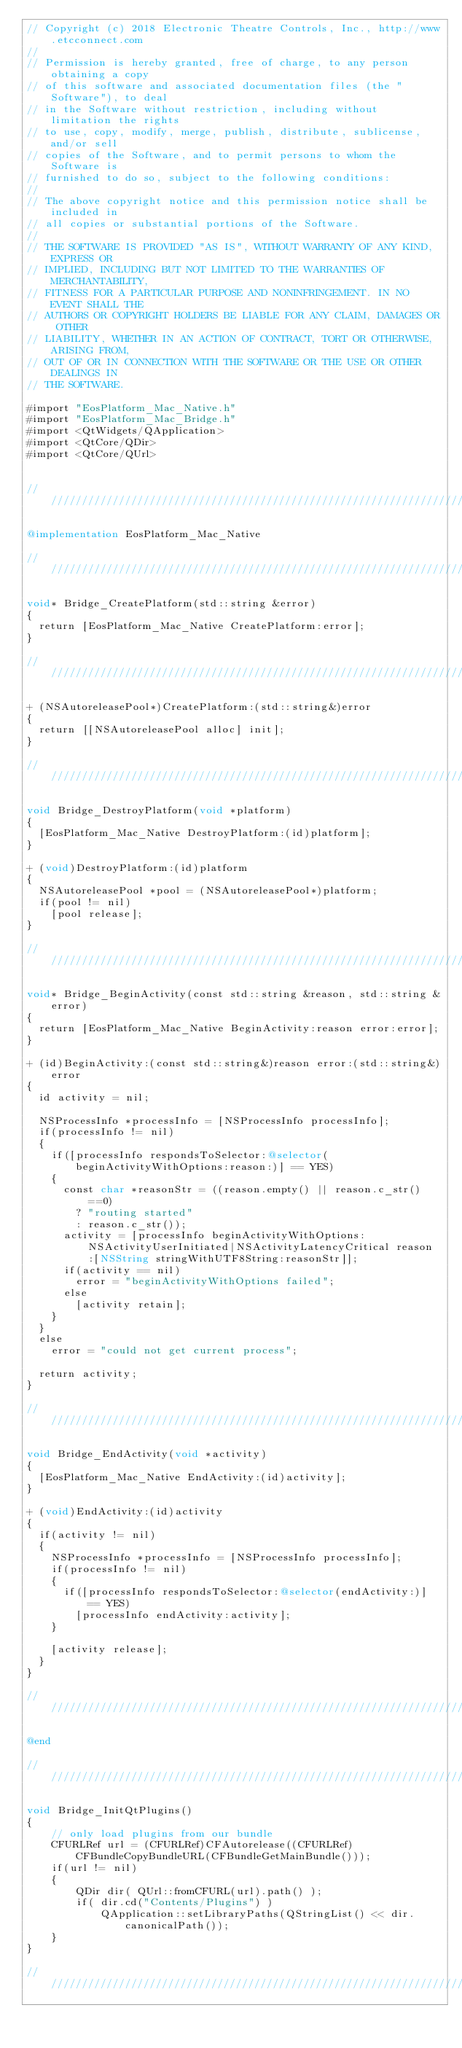<code> <loc_0><loc_0><loc_500><loc_500><_ObjectiveC_>// Copyright (c) 2018 Electronic Theatre Controls, Inc., http://www.etcconnect.com
//
// Permission is hereby granted, free of charge, to any person obtaining a copy
// of this software and associated documentation files (the "Software"), to deal
// in the Software without restriction, including without limitation the rights
// to use, copy, modify, merge, publish, distribute, sublicense, and/or sell
// copies of the Software, and to permit persons to whom the Software is
// furnished to do so, subject to the following conditions:
//
// The above copyright notice and this permission notice shall be included in
// all copies or substantial portions of the Software.
//
// THE SOFTWARE IS PROVIDED "AS IS", WITHOUT WARRANTY OF ANY KIND, EXPRESS OR
// IMPLIED, INCLUDING BUT NOT LIMITED TO THE WARRANTIES OF MERCHANTABILITY,
// FITNESS FOR A PARTICULAR PURPOSE AND NONINFRINGEMENT. IN NO EVENT SHALL THE
// AUTHORS OR COPYRIGHT HOLDERS BE LIABLE FOR ANY CLAIM, DAMAGES OR OTHER
// LIABILITY, WHETHER IN AN ACTION OF CONTRACT, TORT OR OTHERWISE, ARISING FROM,
// OUT OF OR IN CONNECTION WITH THE SOFTWARE OR THE USE OR OTHER DEALINGS IN
// THE SOFTWARE.

#import "EosPlatform_Mac_Native.h"
#import "EosPlatform_Mac_Bridge.h"
#import <QtWidgets/QApplication>
#import <QtCore/QDir>
#import <QtCore/QUrl>


////////////////////////////////////////////////////////////////////////////////

@implementation EosPlatform_Mac_Native

////////////////////////////////////////////////////////////////////////////////

void* Bridge_CreatePlatform(std::string &error)
{
	return [EosPlatform_Mac_Native CreatePlatform:error];
}

////////////////////////////////////////////////////////////////////////////////

+ (NSAutoreleasePool*)CreatePlatform:(std::string&)error
{
	return [[NSAutoreleasePool alloc] init];
}

////////////////////////////////////////////////////////////////////////////////

void Bridge_DestroyPlatform(void *platform)
{
	[EosPlatform_Mac_Native DestroyPlatform:(id)platform];
}

+ (void)DestroyPlatform:(id)platform
{
	NSAutoreleasePool *pool = (NSAutoreleasePool*)platform;
	if(pool != nil)
		[pool release];
}

////////////////////////////////////////////////////////////////////////////////

void* Bridge_BeginActivity(const std::string &reason, std::string &error)
{
	return [EosPlatform_Mac_Native BeginActivity:reason error:error];
}

+ (id)BeginActivity:(const std::string&)reason error:(std::string&)error
{
	id activity = nil;
	
	NSProcessInfo *processInfo = [NSProcessInfo processInfo];
	if(processInfo != nil)
	{
		if([processInfo respondsToSelector:@selector(beginActivityWithOptions:reason:)] == YES)
		{
			const char *reasonStr = ((reason.empty() || reason.c_str()==0)
				? "routing started"
				: reason.c_str());
			activity = [processInfo beginActivityWithOptions:NSActivityUserInitiated|NSActivityLatencyCritical reason:[NSString stringWithUTF8String:reasonStr]];
			if(activity == nil)
				error = "beginActivityWithOptions failed";
			else
				[activity retain];
		}
	}
	else
		error = "could not get current process";
	
	return activity;
}

////////////////////////////////////////////////////////////////////////////////

void Bridge_EndActivity(void *activity)
{
	[EosPlatform_Mac_Native EndActivity:(id)activity];
}

+ (void)EndActivity:(id)activity
{
	if(activity != nil)
	{
		NSProcessInfo *processInfo = [NSProcessInfo processInfo];
		if(processInfo != nil)
		{
			if([processInfo respondsToSelector:@selector(endActivity:)] == YES)
				[processInfo endActivity:activity];
		}
		
		[activity release];
	}
}

////////////////////////////////////////////////////////////////////////////////

@end

////////////////////////////////////////////////////////////////////////////////

void Bridge_InitQtPlugins()
{
    // only load plugins from our bundle
    CFURLRef url = (CFURLRef)CFAutorelease((CFURLRef)CFBundleCopyBundleURL(CFBundleGetMainBundle()));
    if(url != nil)
    {
        QDir dir( QUrl::fromCFURL(url).path() );
        if( dir.cd("Contents/Plugins") )
            QApplication::setLibraryPaths(QStringList() << dir.canonicalPath());
    }
}

////////////////////////////////////////////////////////////////////////////////
</code> 